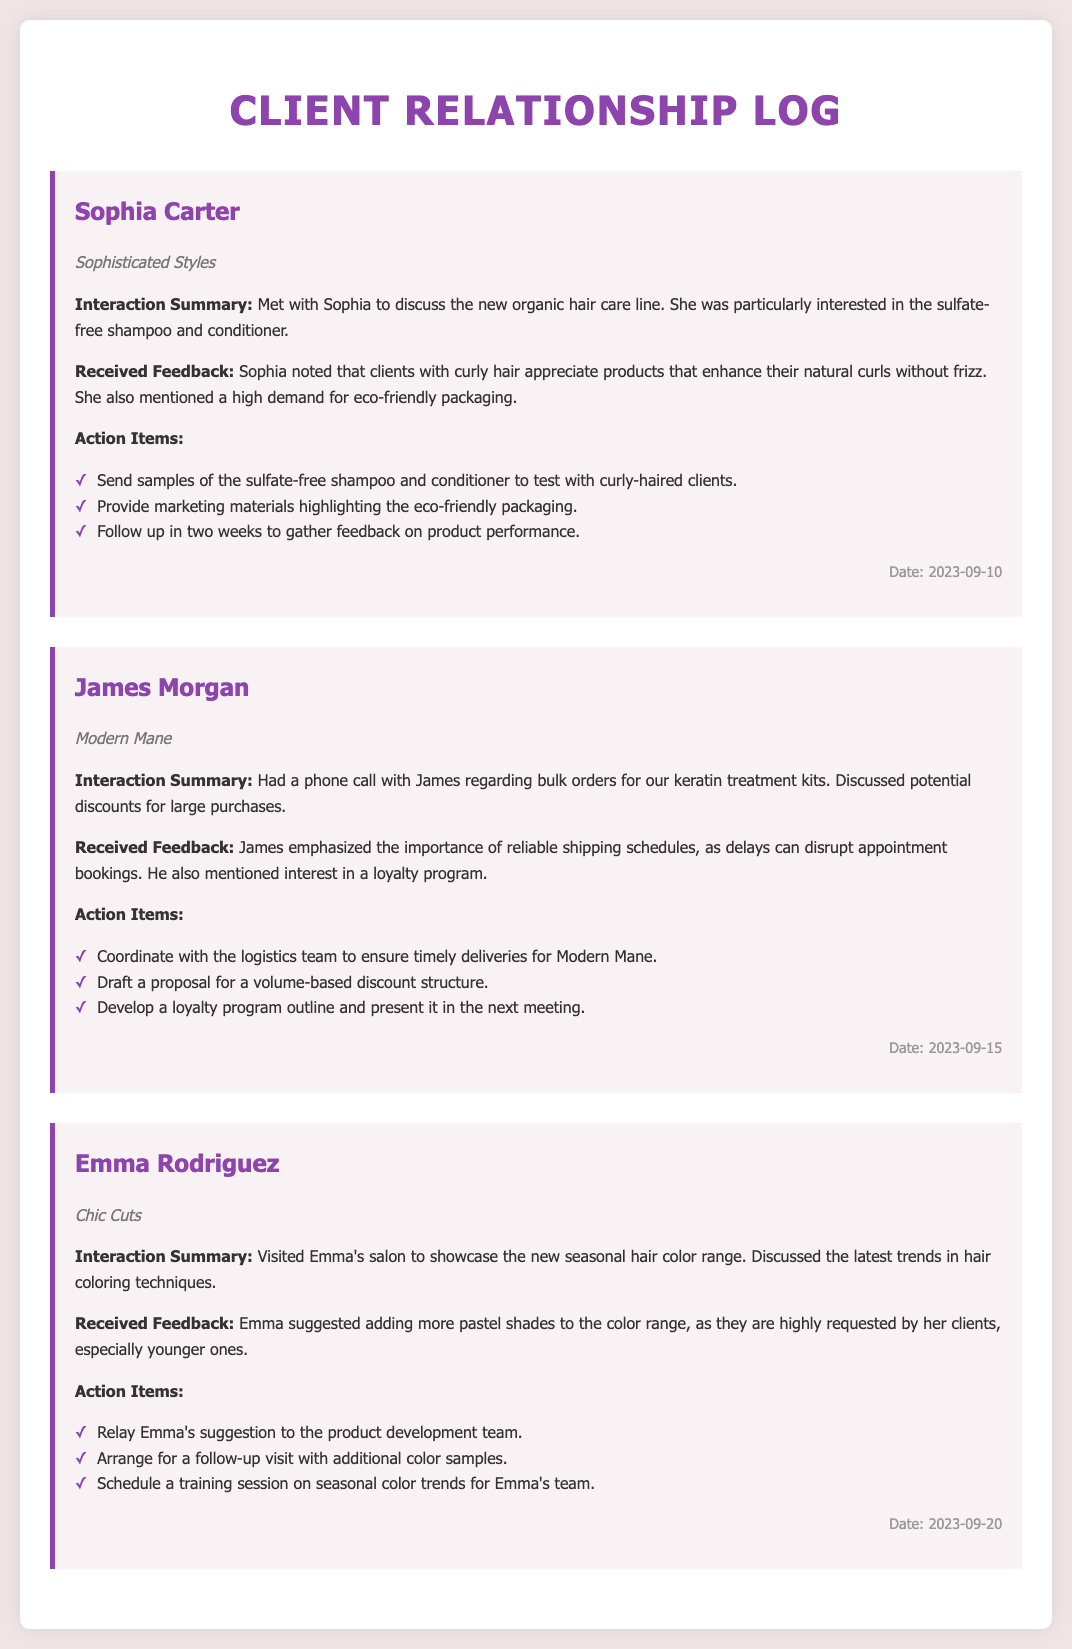What is the name of the stylist from "Sophisticated Styles"? The stylist's name mentioned in the document is Sophia Carter, who is associated with the salon "Sophisticated Styles."
Answer: Sophia Carter What date was the interaction with James Morgan? The interaction with James Morgan took place on September 15, 2023, as indicated in the log entry.
Answer: 2023-09-15 What product did Sophia Carter express interest in? Sophia expressed interest specifically in the sulfate-free shampoo and conditioner from the new organic hair care line.
Answer: Sulfate-free shampoo and conditioner What suggestion did Emma Rodriguez make regarding the color range? Emma suggested adding more pastel shades to the color range due to high demand from her clients, especially younger ones.
Answer: More pastel shades What is one of the action items mentioned for James Morgan? One of the action items for James is to draft a proposal for a volume-based discount structure to be discussed in the next meeting.
Answer: Draft a proposal for a volume-based discount structure How many clients did Sophia mention care about eco-friendly packaging? Sophia noted a high demand for eco-friendly packaging, implying multiple clients express this concern; however, the exact number is not specified.
Answer: Multiple clients What was a key focus during the interaction with Emma Rodriguez? The key focus was showcasing the new seasonal hair color range while discussing the latest trends in hair coloring techniques.
Answer: Seasonal hair color range What was a primary concern for James regarding orders? James emphasized the importance of reliable shipping schedules to avoid disruption in appointment bookings at his salon.
Answer: Reliable shipping schedules What is the salon name of the stylist who provided feedback about keratin treatment kits? The stylist who provided feedback about keratin treatment kits is associated with the salon "Modern Mane."
Answer: Modern Mane 